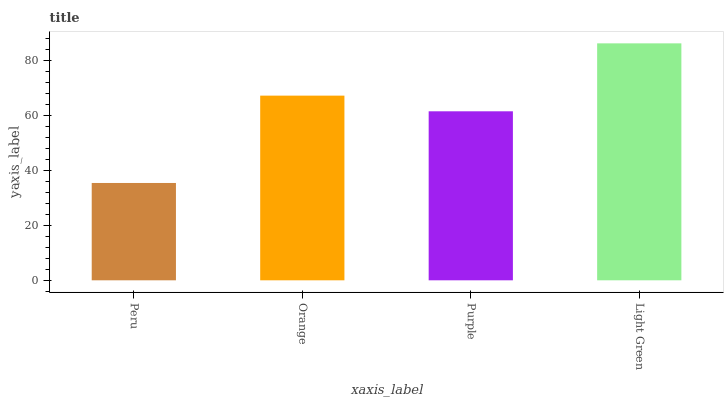Is Peru the minimum?
Answer yes or no. Yes. Is Light Green the maximum?
Answer yes or no. Yes. Is Orange the minimum?
Answer yes or no. No. Is Orange the maximum?
Answer yes or no. No. Is Orange greater than Peru?
Answer yes or no. Yes. Is Peru less than Orange?
Answer yes or no. Yes. Is Peru greater than Orange?
Answer yes or no. No. Is Orange less than Peru?
Answer yes or no. No. Is Orange the high median?
Answer yes or no. Yes. Is Purple the low median?
Answer yes or no. Yes. Is Purple the high median?
Answer yes or no. No. Is Orange the low median?
Answer yes or no. No. 